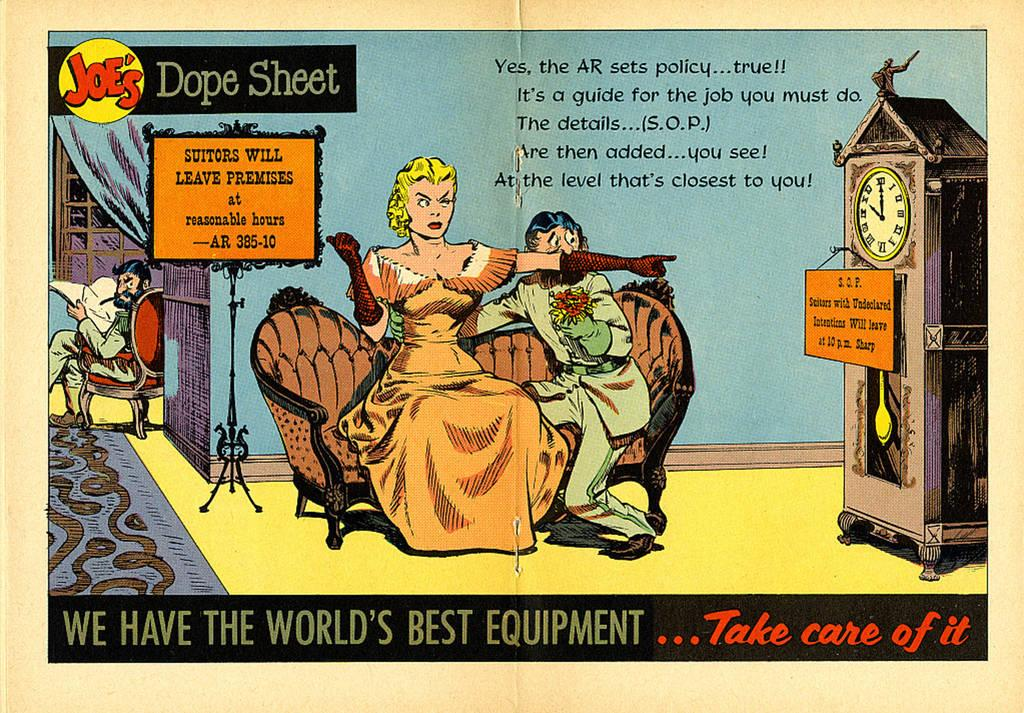<image>
Describe the image concisely. A comic strip page with the headline "Joe's Dope Sheet" written across the top. 